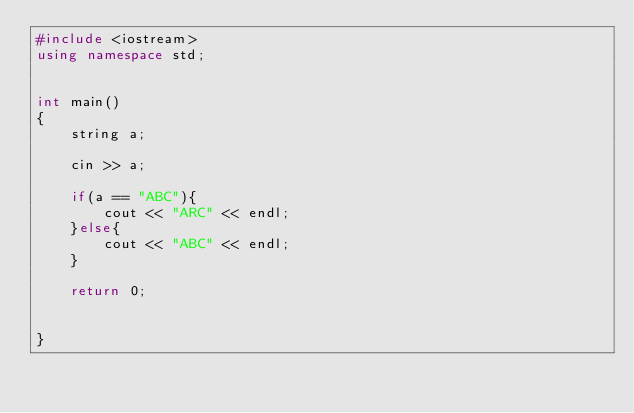<code> <loc_0><loc_0><loc_500><loc_500><_C++_>#include <iostream>
using namespace std;


int main()
{
    string a;

    cin >> a;

    if(a == "ABC"){
        cout << "ARC" << endl;
    }else{
        cout << "ABC" << endl; 
    }

    return 0;
    

}</code> 